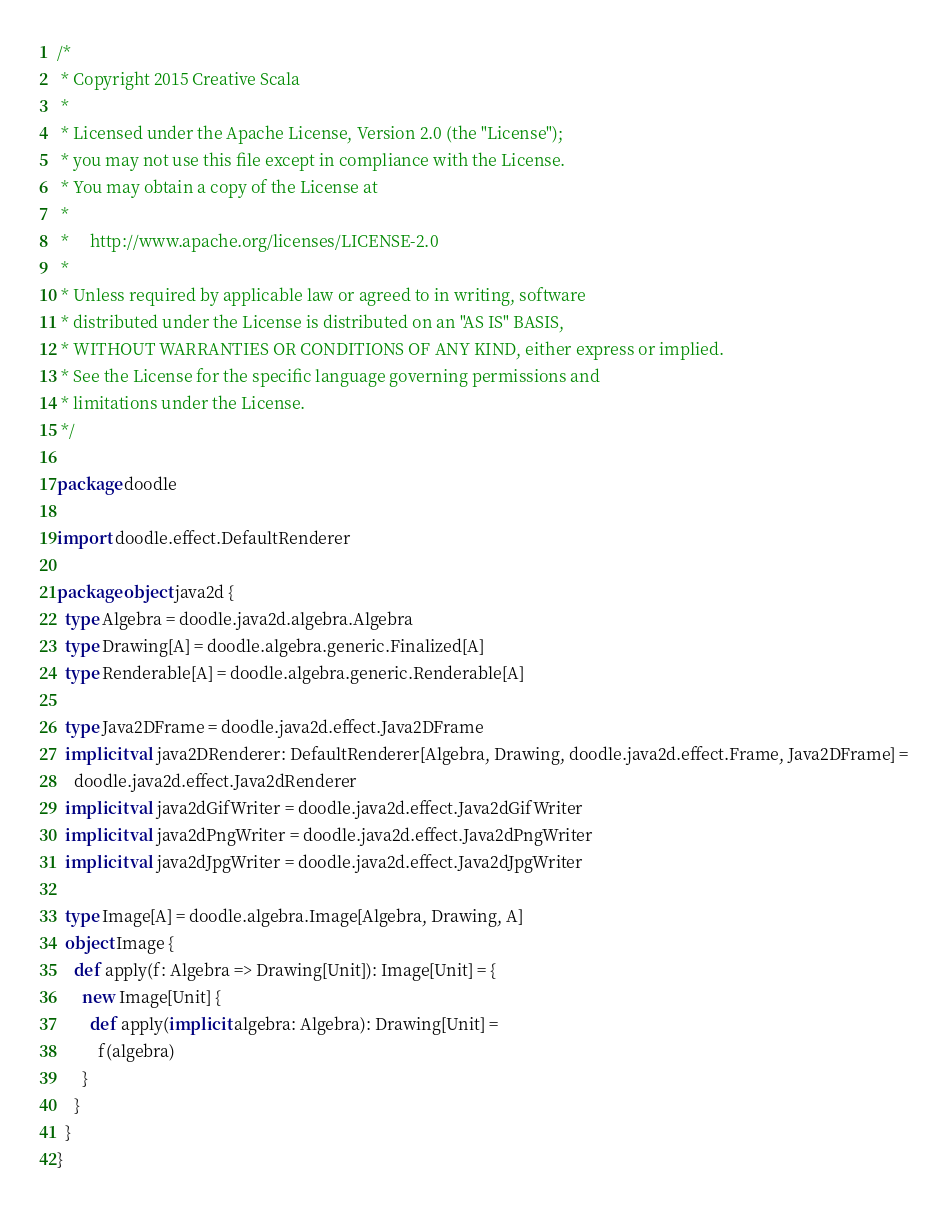<code> <loc_0><loc_0><loc_500><loc_500><_Scala_>/*
 * Copyright 2015 Creative Scala
 *
 * Licensed under the Apache License, Version 2.0 (the "License");
 * you may not use this file except in compliance with the License.
 * You may obtain a copy of the License at
 *
 *     http://www.apache.org/licenses/LICENSE-2.0
 *
 * Unless required by applicable law or agreed to in writing, software
 * distributed under the License is distributed on an "AS IS" BASIS,
 * WITHOUT WARRANTIES OR CONDITIONS OF ANY KIND, either express or implied.
 * See the License for the specific language governing permissions and
 * limitations under the License.
 */

package doodle

import doodle.effect.DefaultRenderer

package object java2d {
  type Algebra = doodle.java2d.algebra.Algebra
  type Drawing[A] = doodle.algebra.generic.Finalized[A]
  type Renderable[A] = doodle.algebra.generic.Renderable[A]

  type Java2DFrame = doodle.java2d.effect.Java2DFrame
  implicit val java2DRenderer: DefaultRenderer[Algebra, Drawing, doodle.java2d.effect.Frame, Java2DFrame] =
    doodle.java2d.effect.Java2dRenderer
  implicit val java2dGifWriter = doodle.java2d.effect.Java2dGifWriter
  implicit val java2dPngWriter = doodle.java2d.effect.Java2dPngWriter
  implicit val java2dJpgWriter = doodle.java2d.effect.Java2dJpgWriter

  type Image[A] = doodle.algebra.Image[Algebra, Drawing, A]
  object Image {
    def apply(f: Algebra => Drawing[Unit]): Image[Unit] = {
      new Image[Unit] {
        def apply(implicit algebra: Algebra): Drawing[Unit] =
          f(algebra)
      }
    }
  }
}
</code> 